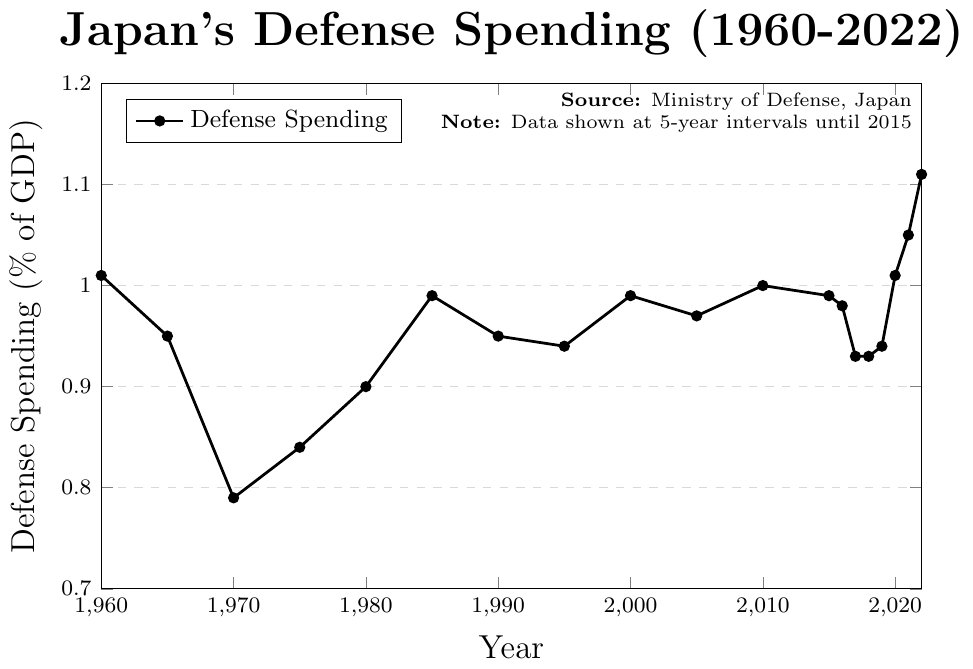what is the overall trend in Japan's defense spending as a percentage of GDP from 1960 to 2022? From the figure, we see that the defense spending as a percentage of GDP started at 1.01% in 1960, then fluctuated over the years but generally increased slightly, reaching 1.11% in 2022. Specifically, it experienced slight decreases in some periods but has trended towards a gradual increase in recent years.
Answer: gradual increase What was Japan's defense spending as a percentage of GDP in 1980 and how does it compare to 2022? In 1980, Japan's defense spending was 0.90% of GDP. Comparing this to 2022, which was 1.11%, we observe that there was an increase of 0.21 percentage points over these years (1.11% - 0.90% = 0.21%).
Answer: increase of 0.21% During which year was the defense spending percentage the lowest? What was that percentage? The lowest defense spending percentage was in 1970, when it was 0.79% of GDP.
Answer: 1970, 0.79% How does the defense spending percentage in 1990 compare to that in 1985? In 1985, the defense spending was 0.99% of GDP, and in 1990, it was 0.95%. There was a decrease of 0.04 percentage points (0.99% - 0.95% = 0.04%).
Answer: 1990 was 0.04% lower than 1985 What is the average defense spending as a percentage of GDP over the decade from 2010 to 2020? The values for the decade are 1.00% (2010), 0.99% (2015), 0.98% (2016), 0.93% (2017), 0.93% (2018), 0.94% (2019), and 1.01% (2020). Adding these values: 1.00 + 0.99 + 0.98 + 0.93 + 0.93 + 0.94 + 1.01 = 6.78. There are 7 data points, so the average is 6.78 / 7 = 0.97%.
Answer: 0.97% In which year was there the highest increase in defense spending percentage compared to the previous recorded year? Comparing subsequent data points, the largest increase occurred from 2021 (1.05%) to 2022 (1.11%), an increase of 0.06 percentage points (1.11% - 1.05% = 0.06%).
Answer: 2022 What are the periods where Japan's defense spending was exactly 0.99% of GDP? From the figure, Japan's defense spending was 0.99% in 1985, 2000, and 2015.
Answer: 1985, 2000, 2015 How many years did it take for defense spending to increase from 0.79% to the next recorded year where spending exceeded 1%? The defense spending was 0.79% in 1970 and reached 1.01% in 2020. The time span between these years is 2020 - 1970 = 50 years.
Answer: 50 years What is the difference in defense spending percentage between 1965 and 1995? In 1965, defense spending was 0.95% of GDP, and in 1995, it was 0.94%. The difference is 0.95% - 0.94% = 0.01%.
Answer: 0.01% 